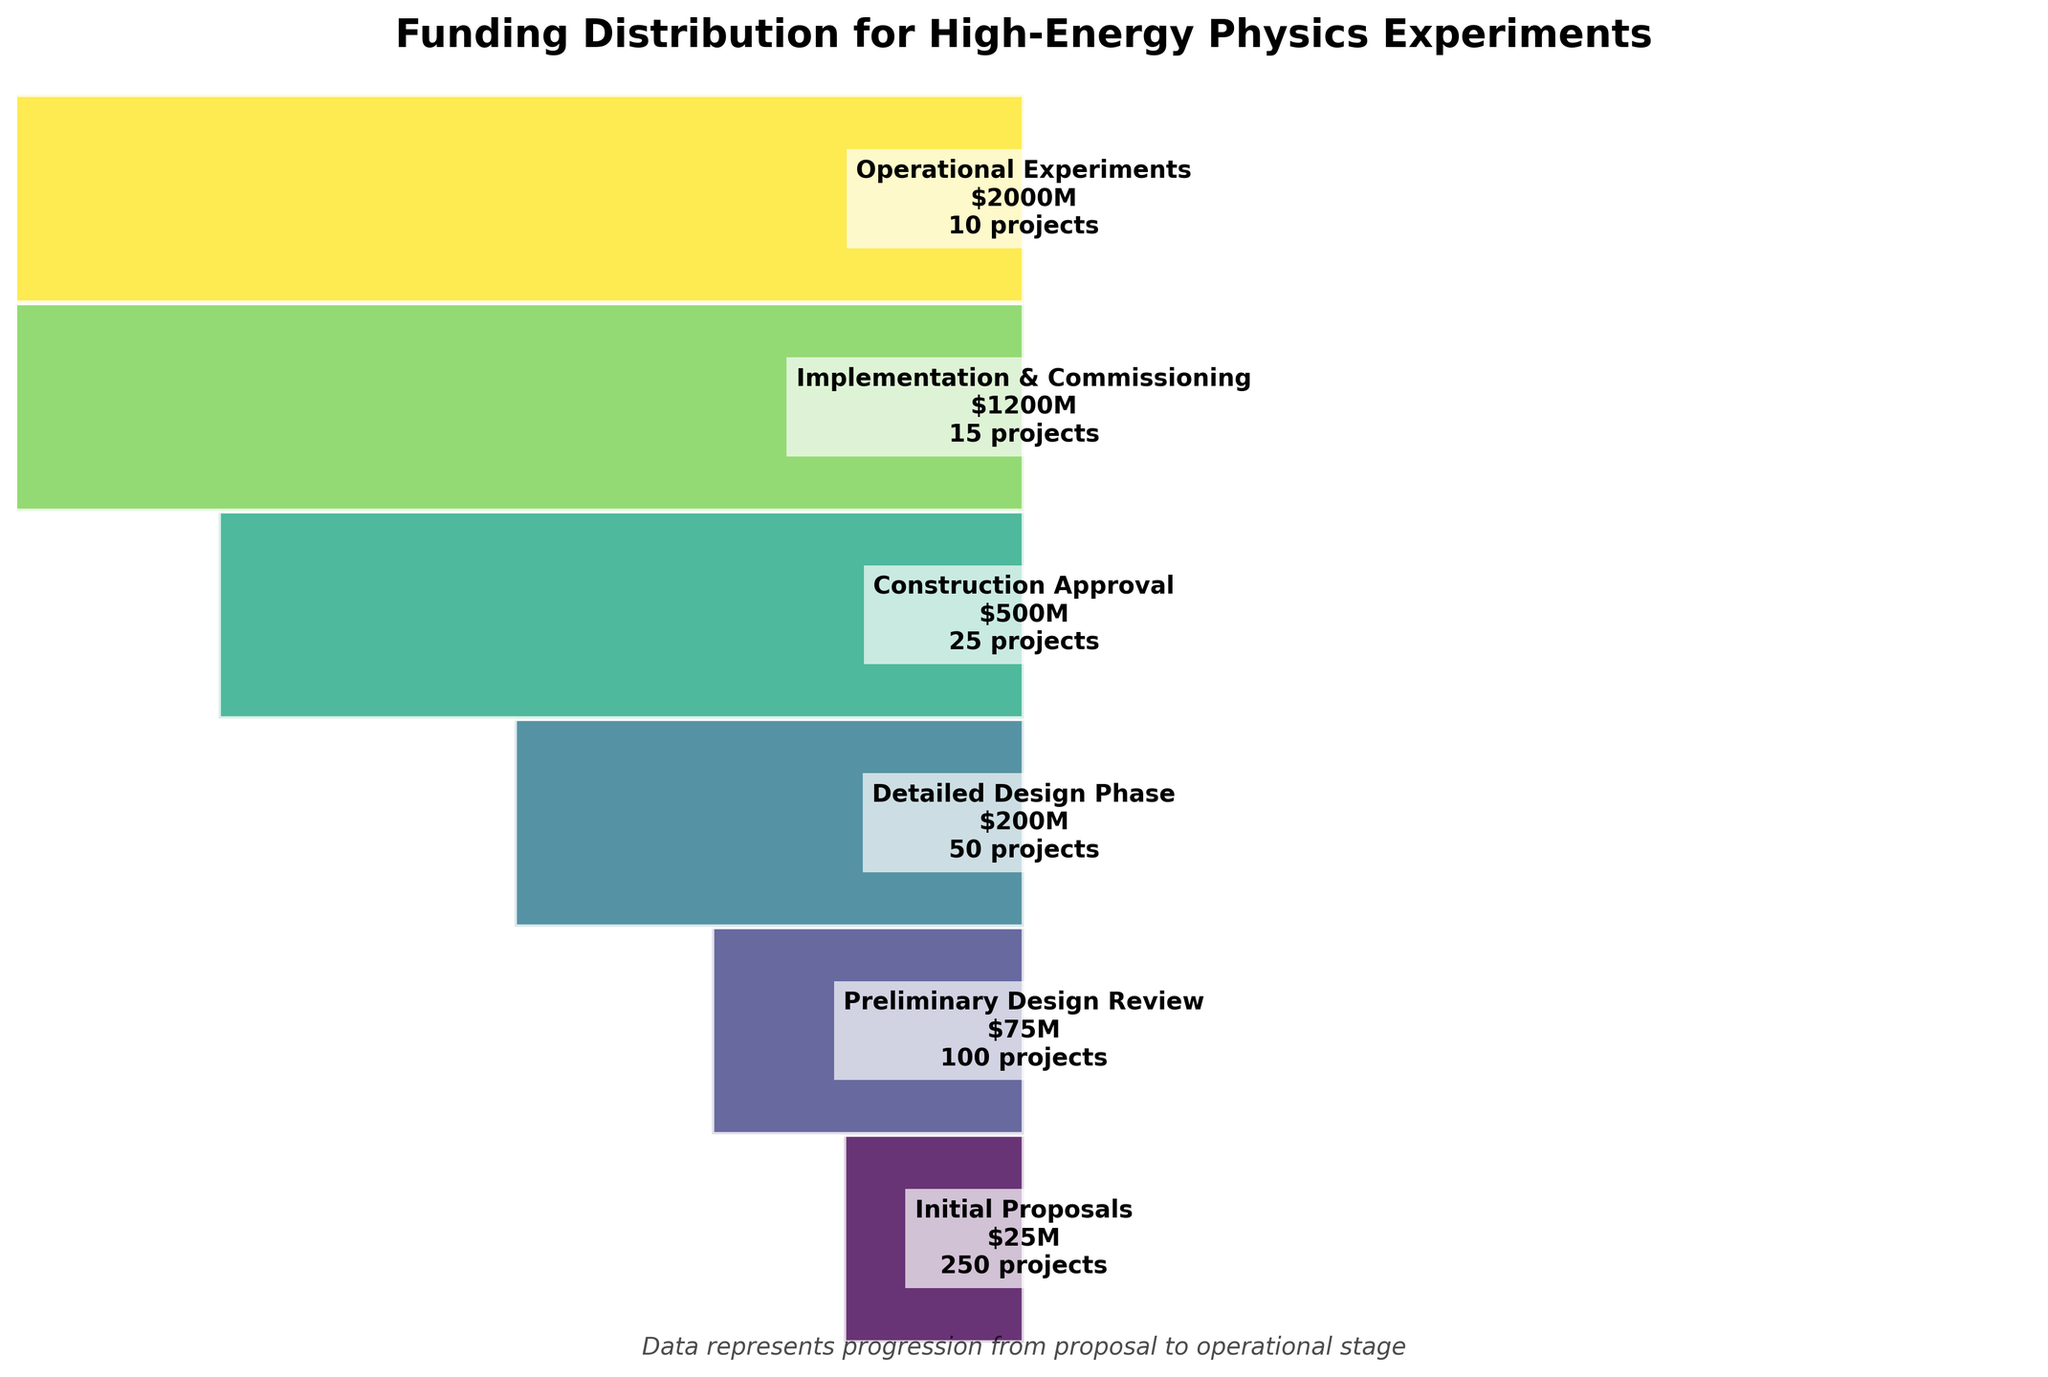What is the title of the funnel chart? The title of the chart is displayed at the top and reads "Funding Distribution for High-Energy Physics Experiments".
Answer: Funding Distribution for High-Energy Physics Experiments How many stages are shown in the funnel chart? By counting the number of distinct sections with text labels on the left side of the chart, we can see that there are six stages.
Answer: Six At which stage is the number of projects reduced by half for the first time? Observing the transitions, the number of projects decreases from 250 during the Initial Proposals stage to 100 at the Preliminary Design Review stage, which is the first time it is reduced by roughly half.
Answer: Preliminary Design Review How much total funding is allocated by the Implementation & Commissioning stage? Adding up the funding amounts up to the Implementation & Commissioning stage: 25M (Initial) + 75M (Preliminary) + 200M (Detailed) + 500M (Construction) + 1200M (Implementation) equals 2000M USD.
Answer: 2000M USD Which stage has the highest funding per project? The stage with the highest total funding of 2000M USD and 10 projects is the Operational Experiments stage. Dividing the funding by the number of projects (2000M/10) gives the highest funding per project of 200M USD.
Answer: Operational Experiments Which stage has the smallest width in the funnel and why? The width of each section corresponds to the square root of funding relative to the maximum funding. The stage with the lowest funding of 25M USD is the Initial Proposals stage, resulting in the smallest width.
Answer: Initial Proposals What is the average number of projects across all stages? Summing the number of projects (250+100+50+25+15+10) equals 450. Dividing by the number of stages (6) gives an average of 75 projects per stage.
Answer: 75 projects Between which two consecutive stages does the overall funding see the most significant percentage increase? Comparing funding: Initial to Preliminary (75/25=3x), Preliminary to Detailed (200/75=2.67x), Detailed to Construction (500/200=2.5x), Construction to Implementation (1200/500=2.4x), and Implementation to Operational (2000/1200=1.67x). The greatest percentage increase is between the Initial Proposals and the Preliminary Design Review stages.
Answer: Initial Proposals to Preliminary Design Review What could be the reason for the increasing width as the stages progress? The increasing width of the funnel sections represents the increasing amount of funding allocated to fewer and more advanced projects as they progress through the stages. This indicates that as projects advance, more funds are concentrated on fewer, more promising experiments.
Answer: More funding on fewer projects How does the transition from Preliminary Design to Detailed Design phase impact the number of projects and the funding allocation? The number of projects reduces from 100 to 50, a 50% decrease. The funding, however, increases from 75M to 200M USD, a significant increase. This shows a substantial investment per project as they enter the Detailed Design phase.
Answer: Projects decrease, funding increases 